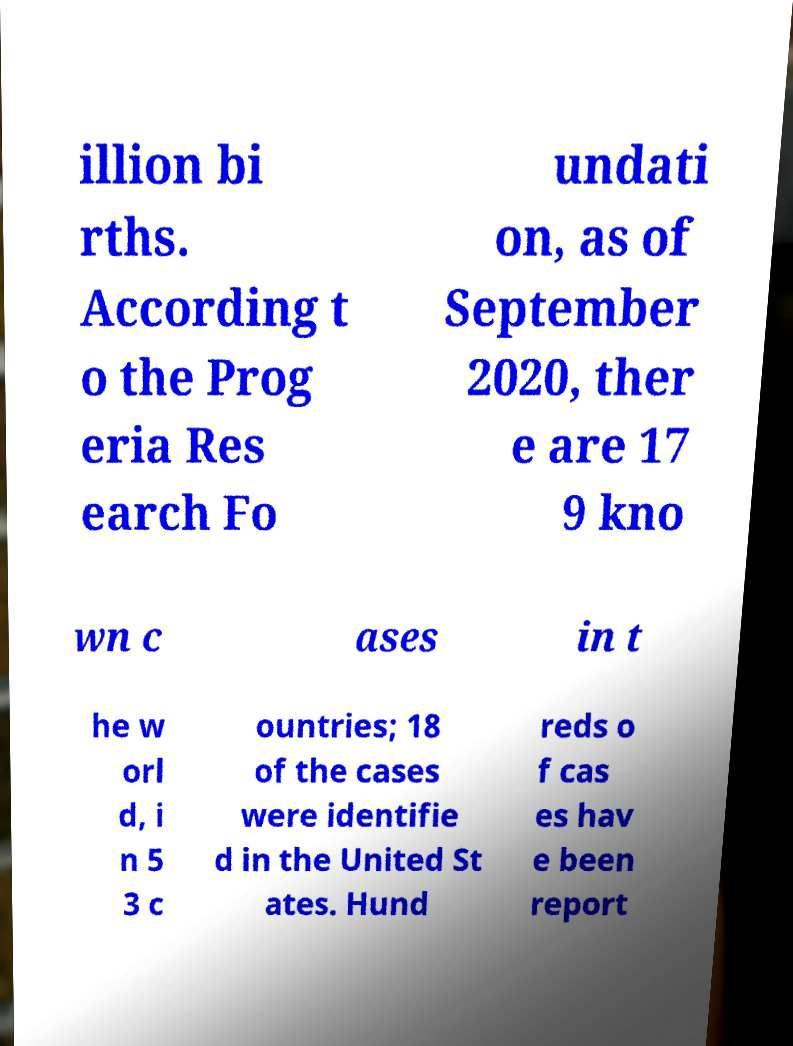Can you accurately transcribe the text from the provided image for me? illion bi rths. According t o the Prog eria Res earch Fo undati on, as of September 2020, ther e are 17 9 kno wn c ases in t he w orl d, i n 5 3 c ountries; 18 of the cases were identifie d in the United St ates. Hund reds o f cas es hav e been report 